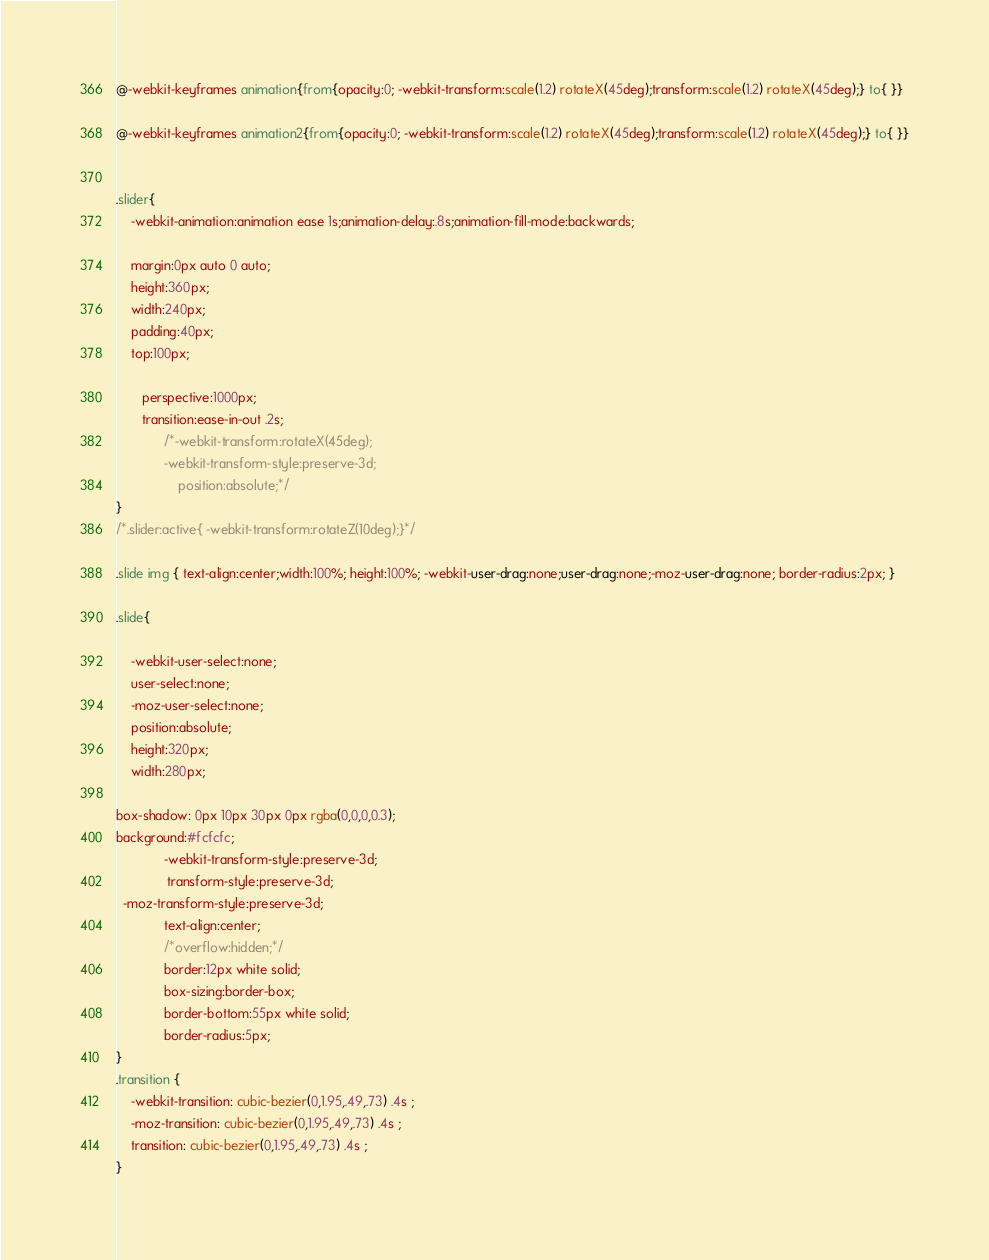<code> <loc_0><loc_0><loc_500><loc_500><_CSS_>@-webkit-keyframes animation{from{opacity:0; -webkit-transform:scale(1.2) rotateX(45deg);transform:scale(1.2) rotateX(45deg);} to{ }}

@-webkit-keyframes animation2{from{opacity:0; -webkit-transform:scale(1.2) rotateX(45deg);transform:scale(1.2) rotateX(45deg);} to{ }}


.slider{
    -webkit-animation:animation ease 1s;animation-delay:.8s;animation-fill-mode:backwards;
 
    margin:0px auto 0 auto;
    height:360px;
    width:240px;
    padding:40px;
    top:100px;

       perspective:1000px;
       transition:ease-in-out .2s;
             /*-webkit-transform:rotateX(45deg);
             -webkit-transform-style:preserve-3d;
                 position:absolute;*/
}
/*.slider:active{ -webkit-transform:rotateZ(10deg);}*/

.slide img { text-align:center;width:100%; height:100%; -webkit-user-drag:none;user-drag:none;-moz-user-drag:none; border-radius:2px; }

.slide{

    -webkit-user-select:none;
    user-select:none;
    -moz-user-select:none;
    position:absolute;
    height:320px;
    width:280px;

box-shadow: 0px 10px 30px 0px rgba(0,0,0,0.3);
background:#fcfcfc;
             -webkit-transform-style:preserve-3d;
              transform-style:preserve-3d;
  -moz-transform-style:preserve-3d;
             text-align:center;
             /*overflow:hidden;*/
             border:12px white solid;
             box-sizing:border-box;
             border-bottom:55px white solid;
             border-radius:5px; 
}
.transition {
    -webkit-transition: cubic-bezier(0,1.95,.49,.73) .4s ;
    -moz-transition: cubic-bezier(0,1.95,.49,.73) .4s ;
    transition: cubic-bezier(0,1.95,.49,.73) .4s ;
}




</code> 